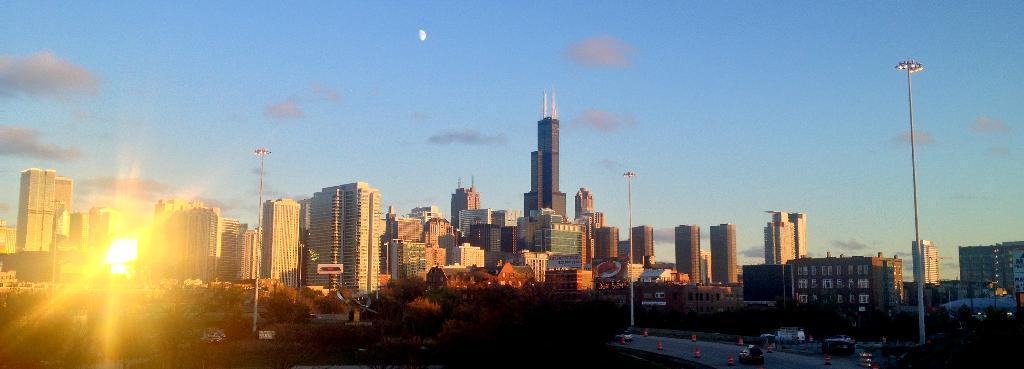Describe this image in one or two sentences. In this image in the center there are some buildings, poles and lights. At the bottom there are some trees and road, on the road there are some vehicles. On the top of the image there is sky. 